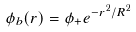Convert formula to latex. <formula><loc_0><loc_0><loc_500><loc_500>\phi _ { b } ( r ) = \phi _ { + } e ^ { - r ^ { 2 } / R ^ { 2 } }</formula> 